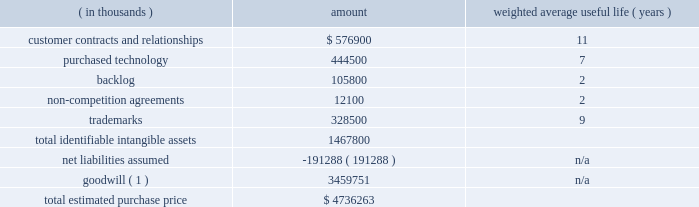Table of contents adobe inc .
Notes to consolidated financial statements ( continued ) the table below represents the preliminary purchase price allocation to the acquired net tangible and intangible assets of marketo based on their estimated fair values as of the acquisition date and the associated estimated useful lives at that date .
The fair values assigned to assets acquired and liabilities assumed are based on management 2019s best estimates and assumptions as of the reporting date and are considered preliminary pending finalization of valuation analyses pertaining to intangible assets acquired , deferred revenue and tax liabilities assumed including the calculation of deferred tax assets and liabilities .
( in thousands ) amount weighted average useful life ( years ) .
_________________________________________ ( 1 ) non-deductible for tax-purposes .
Identifiable intangible assets 2014customer relationships consist of marketo 2019s contractual relationships and customer loyalty related to their enterprise and commercial customers as well as technology partner relationships .
The estimated fair value of the customer contracts and relationships was determined based on projected cash flows attributable to the asset .
Purchased technology acquired primarily consists of marketo 2019s cloud-based engagement marketing software platform .
The estimated fair value of the purchased technology was determined based on the expected future cost savings resulting from ownership of the asset .
Backlog relates to subscription contracts and professional services .
Non-compete agreements include agreements with key marketo employees that preclude them from competing against marketo for a period of two years from the acquisition date .
Trademarks include the marketo trade name , which is well known in the marketing ecosystem .
We amortize the fair value of these intangible assets on a straight-line basis over their respective estimated useful lives .
Goodwill 2014approximately $ 3.46 billion has been allocated to goodwill , and has been allocated in full to the digital experience reportable segment .
Goodwill represents the excess of the purchase price over the fair value of the underlying acquired net tangible and intangible assets .
The factors that contributed to the recognition of goodwill included securing buyer-specific synergies that increase revenue and profits and are not otherwise available to a marketplace participant , acquiring a talented workforce and cost savings opportunities .
Net liabilities assumed 2014marketo 2019s tangible assets and liabilities as of october 31 , 2018 were reviewed and adjusted to their fair value as necessary .
The net liabilities assumed included , among other items , $ 100.1 million in accrued expenses , $ 74.8 million in deferred revenue and $ 182.6 million in deferred tax liabilities , which were partially offset by $ 54.9 million in cash and cash equivalents and $ 72.4 million in trade receivables acquired .
Deferred revenue 2014included in net liabilities assumed is marketo 2019s deferred revenue which represents advance payments from customers related to subscription contracts and professional services .
We estimated our obligation related to the deferred revenue using the cost build-up approach .
The cost build-up approach determines fair value by estimating the direct and indirect costs related to supporting the obligation plus an assumed operating margin .
The sum of the costs and assumed operating profit approximates , in theory , the amount that marketo would be required to pay a third party to assume the obligation .
The estimated costs to fulfill the obligation were based on the near-term projected cost structure for subscription and professional services .
As a result , we recorded an adjustment to reduce marketo 2019s carrying value of deferred revenue to $ 74.8 million , which represents our estimate of the fair value of the contractual obligations assumed based on a preliminary valuation. .
What is the estimated yearly amortization expense related to trademarks? 
Computations: (328500 / 9)
Answer: 36500.0. Table of contents adobe inc .
Notes to consolidated financial statements ( continued ) the table below represents the preliminary purchase price allocation to the acquired net tangible and intangible assets of marketo based on their estimated fair values as of the acquisition date and the associated estimated useful lives at that date .
The fair values assigned to assets acquired and liabilities assumed are based on management 2019s best estimates and assumptions as of the reporting date and are considered preliminary pending finalization of valuation analyses pertaining to intangible assets acquired , deferred revenue and tax liabilities assumed including the calculation of deferred tax assets and liabilities .
( in thousands ) amount weighted average useful life ( years ) .
_________________________________________ ( 1 ) non-deductible for tax-purposes .
Identifiable intangible assets 2014customer relationships consist of marketo 2019s contractual relationships and customer loyalty related to their enterprise and commercial customers as well as technology partner relationships .
The estimated fair value of the customer contracts and relationships was determined based on projected cash flows attributable to the asset .
Purchased technology acquired primarily consists of marketo 2019s cloud-based engagement marketing software platform .
The estimated fair value of the purchased technology was determined based on the expected future cost savings resulting from ownership of the asset .
Backlog relates to subscription contracts and professional services .
Non-compete agreements include agreements with key marketo employees that preclude them from competing against marketo for a period of two years from the acquisition date .
Trademarks include the marketo trade name , which is well known in the marketing ecosystem .
We amortize the fair value of these intangible assets on a straight-line basis over their respective estimated useful lives .
Goodwill 2014approximately $ 3.46 billion has been allocated to goodwill , and has been allocated in full to the digital experience reportable segment .
Goodwill represents the excess of the purchase price over the fair value of the underlying acquired net tangible and intangible assets .
The factors that contributed to the recognition of goodwill included securing buyer-specific synergies that increase revenue and profits and are not otherwise available to a marketplace participant , acquiring a talented workforce and cost savings opportunities .
Net liabilities assumed 2014marketo 2019s tangible assets and liabilities as of october 31 , 2018 were reviewed and adjusted to their fair value as necessary .
The net liabilities assumed included , among other items , $ 100.1 million in accrued expenses , $ 74.8 million in deferred revenue and $ 182.6 million in deferred tax liabilities , which were partially offset by $ 54.9 million in cash and cash equivalents and $ 72.4 million in trade receivables acquired .
Deferred revenue 2014included in net liabilities assumed is marketo 2019s deferred revenue which represents advance payments from customers related to subscription contracts and professional services .
We estimated our obligation related to the deferred revenue using the cost build-up approach .
The cost build-up approach determines fair value by estimating the direct and indirect costs related to supporting the obligation plus an assumed operating margin .
The sum of the costs and assumed operating profit approximates , in theory , the amount that marketo would be required to pay a third party to assume the obligation .
The estimated costs to fulfill the obligation were based on the near-term projected cost structure for subscription and professional services .
As a result , we recorded an adjustment to reduce marketo 2019s carrying value of deferred revenue to $ 74.8 million , which represents our estimate of the fair value of the contractual obligations assumed based on a preliminary valuation. .
What portion of the total estimated purchase price is dedicated to goodwill? 
Computations: (3459751 / 4736263)
Answer: 0.73048. 